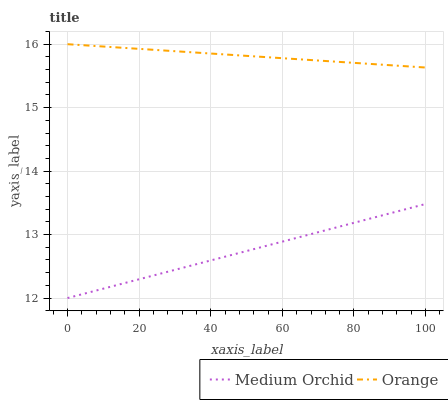Does Medium Orchid have the maximum area under the curve?
Answer yes or no. No. Is Medium Orchid the smoothest?
Answer yes or no. No. Does Medium Orchid have the highest value?
Answer yes or no. No. Is Medium Orchid less than Orange?
Answer yes or no. Yes. Is Orange greater than Medium Orchid?
Answer yes or no. Yes. Does Medium Orchid intersect Orange?
Answer yes or no. No. 